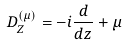<formula> <loc_0><loc_0><loc_500><loc_500>D _ { Z } ^ { ( \mu ) } = - i \frac { d } { d z } + \mu</formula> 